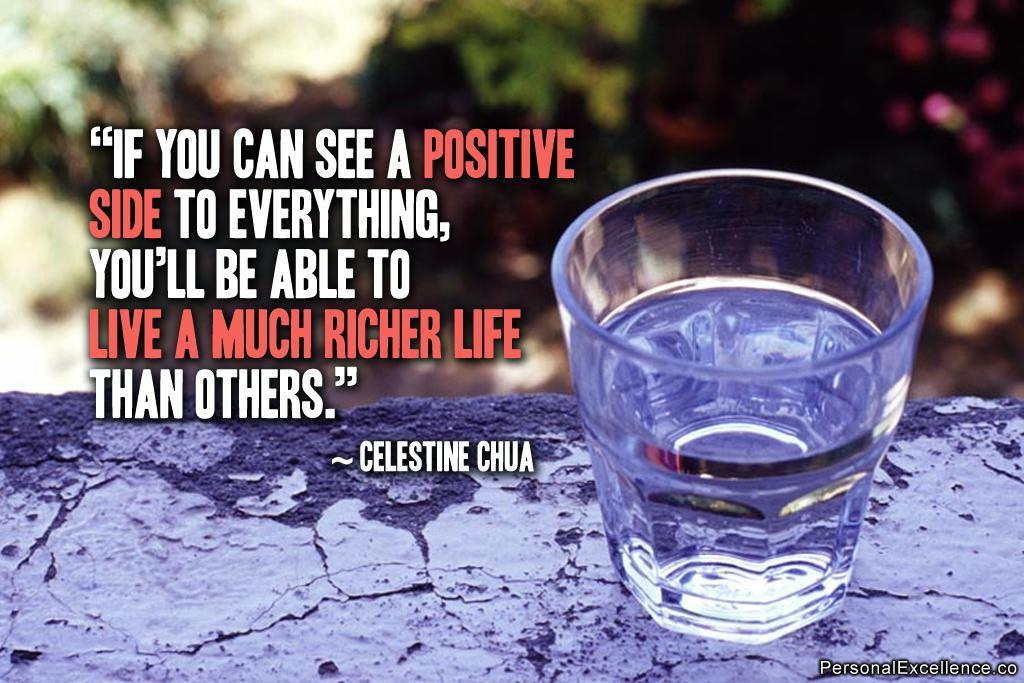Provide a one-sentence caption for the provided image. A positive quote by Celestine Chua is written next to a glass of water. 